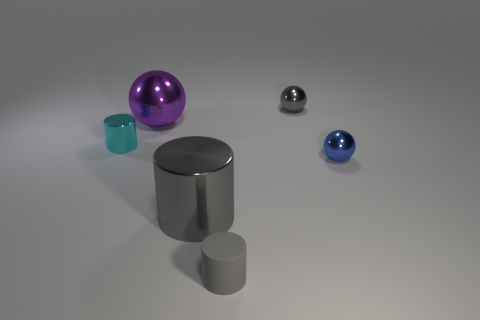How might you categorize the different textures visible on these objects? The textures of the objects in the image can be categorized into two groups: the reflective textures indicating metallic or polished materials, as seen on the big purple and blue spheres, and the diffuse textures suggesting matte or rough surfaces, such as the one on the cylinders. 